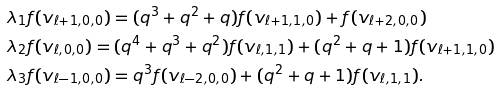Convert formula to latex. <formula><loc_0><loc_0><loc_500><loc_500>& \lambda _ { 1 } f ( v _ { \ell + 1 , 0 , 0 } ) = ( q ^ { 3 } + q ^ { 2 } + q ) f ( v _ { \ell + 1 , 1 , 0 } ) + f ( v _ { \ell + 2 , 0 , 0 } ) \\ & \lambda _ { 2 } f ( v _ { \ell , 0 , 0 } ) = ( q ^ { 4 } + q ^ { 3 } + q ^ { 2 } ) f ( v _ { \ell , 1 , 1 } ) + ( q ^ { 2 } + q + 1 ) f ( v _ { \ell + 1 , 1 , 0 } ) \\ & \lambda _ { 3 } f ( v _ { \ell - 1 , 0 , 0 } ) = q ^ { 3 } f ( v _ { \ell - 2 , 0 , 0 } ) + ( q ^ { 2 } + q + 1 ) f ( v _ { \ell , 1 , 1 } ) .</formula> 